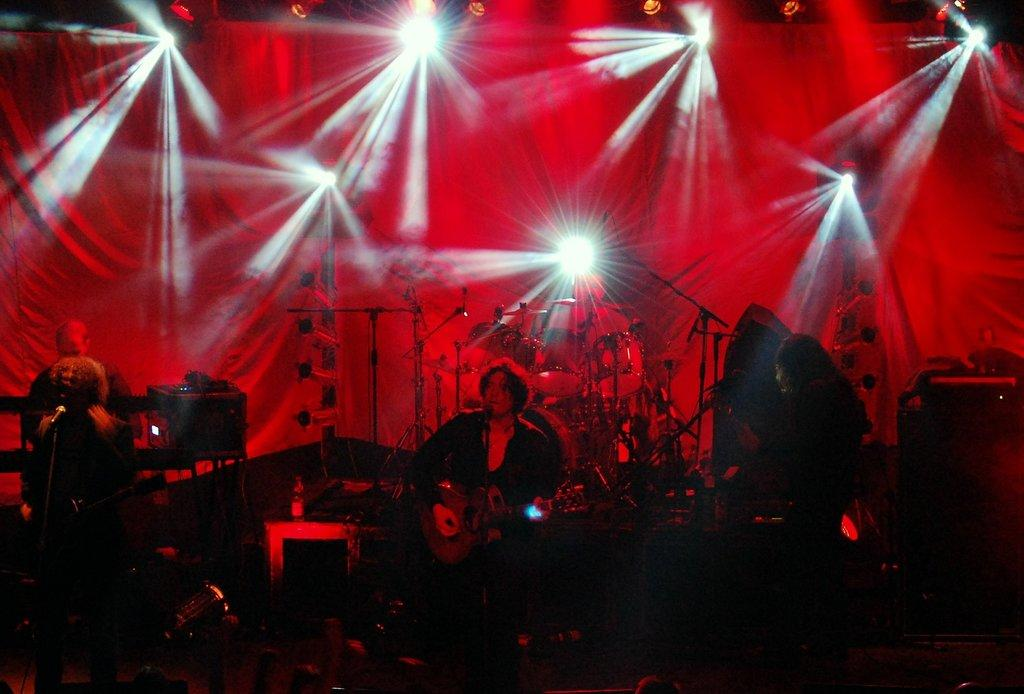How many people are playing guitar in the image? There are three persons playing guitar in the image. What is the position of the person who is not playing guitar? There is a person standing on the floor. What other objects are present in the image besides the guitar players? There are musical instruments in the image. Can you describe the background of the image? There is a curtain and lights in the background. How many oranges are on the guitar in the image? There are no oranges present in the image. Can you describe the fly that is flying around the guitar player? There is no fly present in the image. 